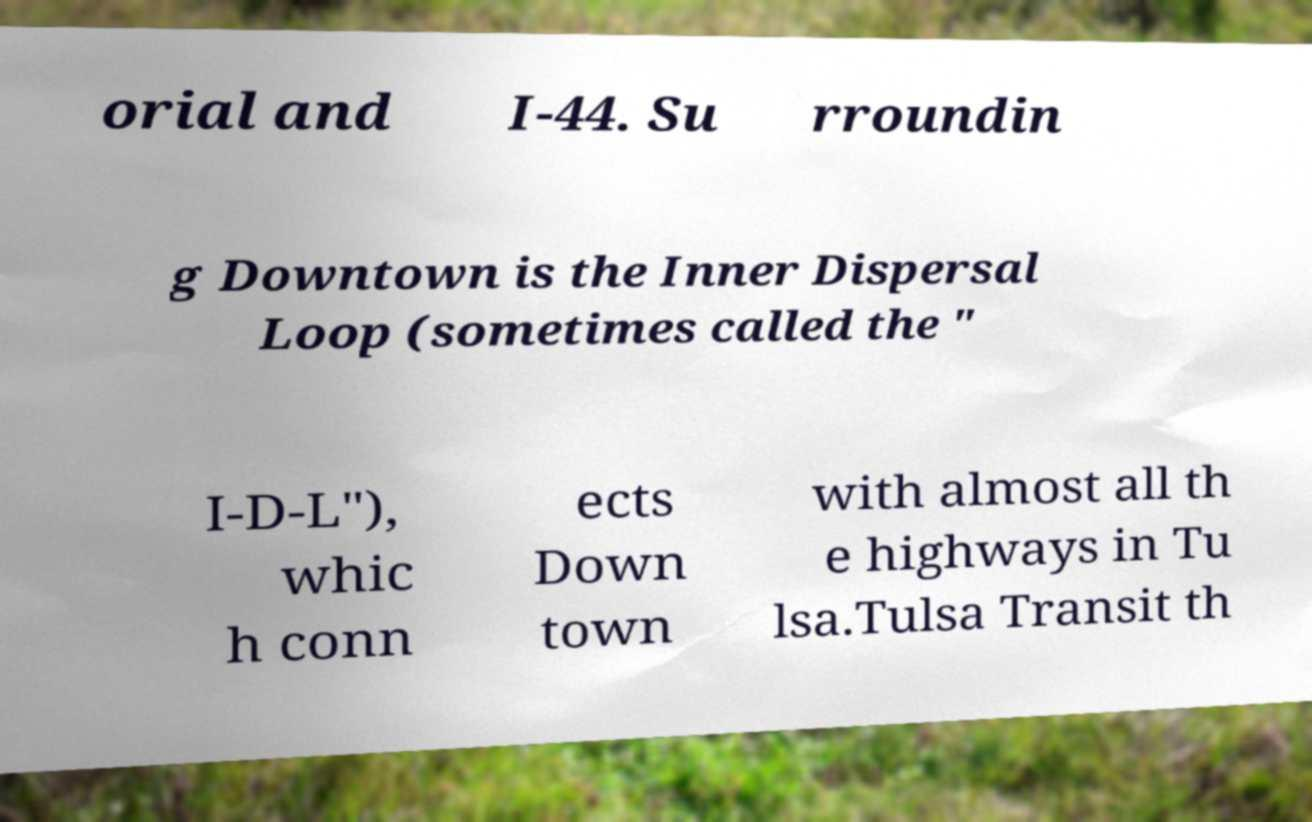Can you read and provide the text displayed in the image?This photo seems to have some interesting text. Can you extract and type it out for me? orial and I-44. Su rroundin g Downtown is the Inner Dispersal Loop (sometimes called the " I-D-L"), whic h conn ects Down town with almost all th e highways in Tu lsa.Tulsa Transit th 